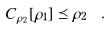Convert formula to latex. <formula><loc_0><loc_0><loc_500><loc_500>C _ { \rho _ { 2 } } [ \rho _ { 1 } ] \preceq \rho _ { 2 } \ .</formula> 